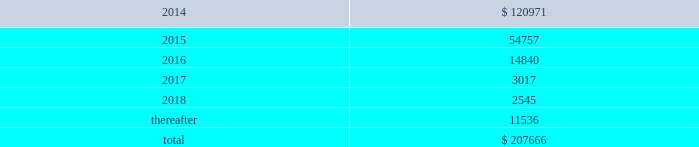Interest expense related to capital lease obligations was $ 1.7 million during both the years ended december 31 , 2013 and 2012 , and $ 1.5 million during the year ended december 31 , 2011 .
Purchase commitments in the table below , we set forth our enforceable and legally binding purchase obligations as of december 31 , 2013 .
Some of the amounts included in the table are based on management 2019s estimates and assumptions about these obligations , including their duration , the possibility of renewal , anticipated actions by third parties , and other factors .
Because these estimates and assumptions are necessarily subjective , our actual payments may vary from those reflected in the table .
Purchase orders made in the ordinary course of business are excluded from the table below .
Any amounts for which we are liable under purchase orders are reflected on the consolidated balance sheets as accounts payable and accrued liabilities .
These obligations relate to various purchase agreements for items such as minimum amounts of fiber and energy purchases over periods ranging from one to 15 years .
Total purchase commitments are as follows ( dollars in thousands ) : .
The company purchased a total of $ 61.7 million , $ 27.7 million , and $ 28.5 million during the years ended december 31 , 2013 , 2012 , and 2011 , respectively , under these purchase agreements .
The increase in purchase commitments in 2014 , compared with 2013 , relates to the acquisition of boise in fourth quarter 2013 .
Environmental liabilities the potential costs for various environmental matters are uncertain due to such factors as the unknown magnitude of possible cleanup costs , the complexity and evolving nature of governmental laws and regulations and their interpretations , and the timing , varying costs and effectiveness of alternative cleanup technologies .
From 1994 through 2013 , remediation costs at the company 2019s mills and corrugated plants totaled approximately $ 3.2 million .
At december 31 , 2013 , the company had $ 34.1 million of environmental-related reserves recorded on its consolidated balance sheet .
Of the $ 34.1 million , approximately $ 26.5 million related to environmental- related asset retirement obligations discussed in note 14 , asset retirement obligations , and $ 7.6 million related to our estimate of other environmental contingencies .
The company recorded $ 7.8 million in 201caccrued liabilities 201d and $ 26.3 million in 201cother long-term liabilities 201d on the consolidated balance sheet .
Liabilities recorded for environmental contingencies are estimates of the probable costs based upon available information and assumptions .
Because of these uncertainties , pca 2019s estimates may change .
As of the date of this filing , the company believes that it is not reasonably possible that future environmental expenditures for remediation costs and asset retirement obligations above the $ 34.1 million accrued as of december 31 , 2013 , will have a material impact on its financial condition , results of operations , or cash flows .
Guarantees and indemnifications we provide guarantees , indemnifications , and other assurances to third parties in the normal course of our business .
These include tort indemnifications , environmental assurances , and representations and warranties in commercial agreements .
At december 31 , 2013 , we are not aware of any material liabilities arising from any guarantee , indemnification , or financial assurance we have provided .
If we determined such a liability was probable and subject to reasonable determination , we would accrue for it at that time. .
At december 31 , 2013 , what was the percent of the environmental-related reserves that was related to asset retirement obligations? 
Rationale: at december 31 , 2013 , 77.7% of environmental-related reserves was related to asset retirement obligations
Computations: (26.5 / 34.1)
Answer: 0.77713. 